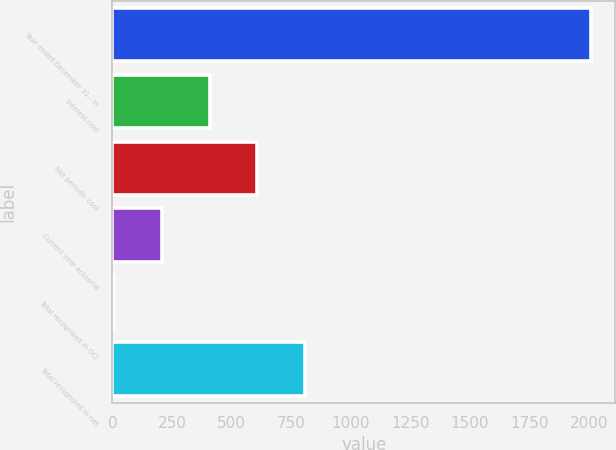Convert chart. <chart><loc_0><loc_0><loc_500><loc_500><bar_chart><fcel>Year ended December 31 - in<fcel>Interest cost<fcel>Net periodic cost<fcel>Current year actuarial<fcel>Total recognized in OCI<fcel>Total recognized in net<nl><fcel>2010<fcel>408.4<fcel>608.6<fcel>208.2<fcel>8<fcel>808.8<nl></chart> 